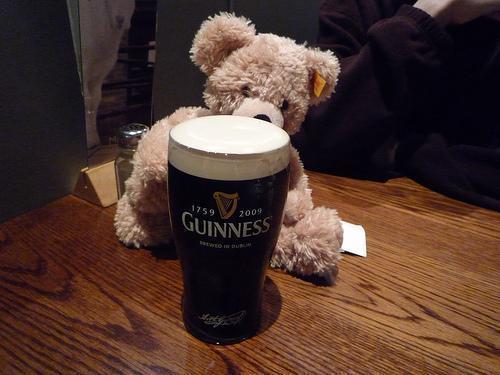How many cups are in the photo?
Give a very brief answer. 1. 